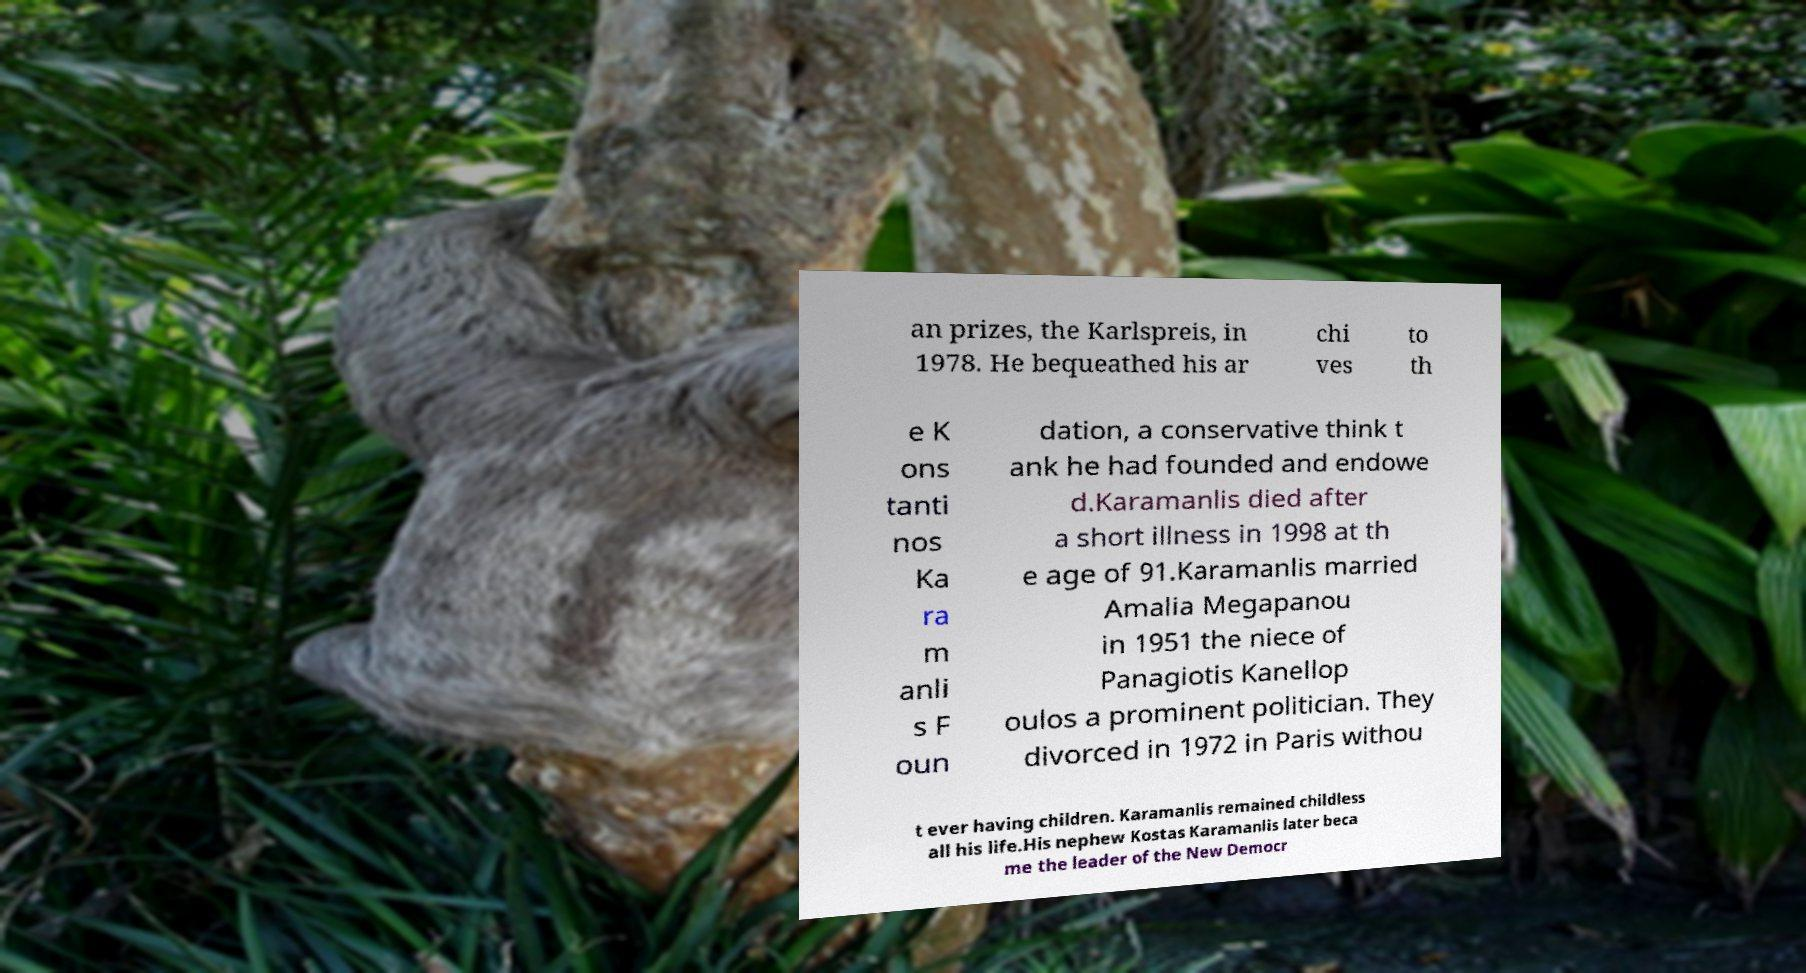Could you extract and type out the text from this image? an prizes, the Karlspreis, in 1978. He bequeathed his ar chi ves to th e K ons tanti nos Ka ra m anli s F oun dation, a conservative think t ank he had founded and endowe d.Karamanlis died after a short illness in 1998 at th e age of 91.Karamanlis married Amalia Megapanou in 1951 the niece of Panagiotis Kanellop oulos a prominent politician. They divorced in 1972 in Paris withou t ever having children. Karamanlis remained childless all his life.His nephew Kostas Karamanlis later beca me the leader of the New Democr 